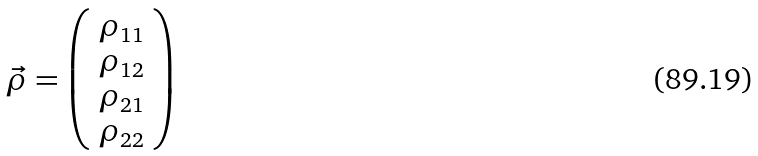<formula> <loc_0><loc_0><loc_500><loc_500>\vec { \rho } = \left ( \begin{array} { c } \rho _ { 1 1 } \\ \rho _ { 1 2 } \\ \rho _ { 2 1 } \\ \rho _ { 2 2 } \end{array} \right )</formula> 